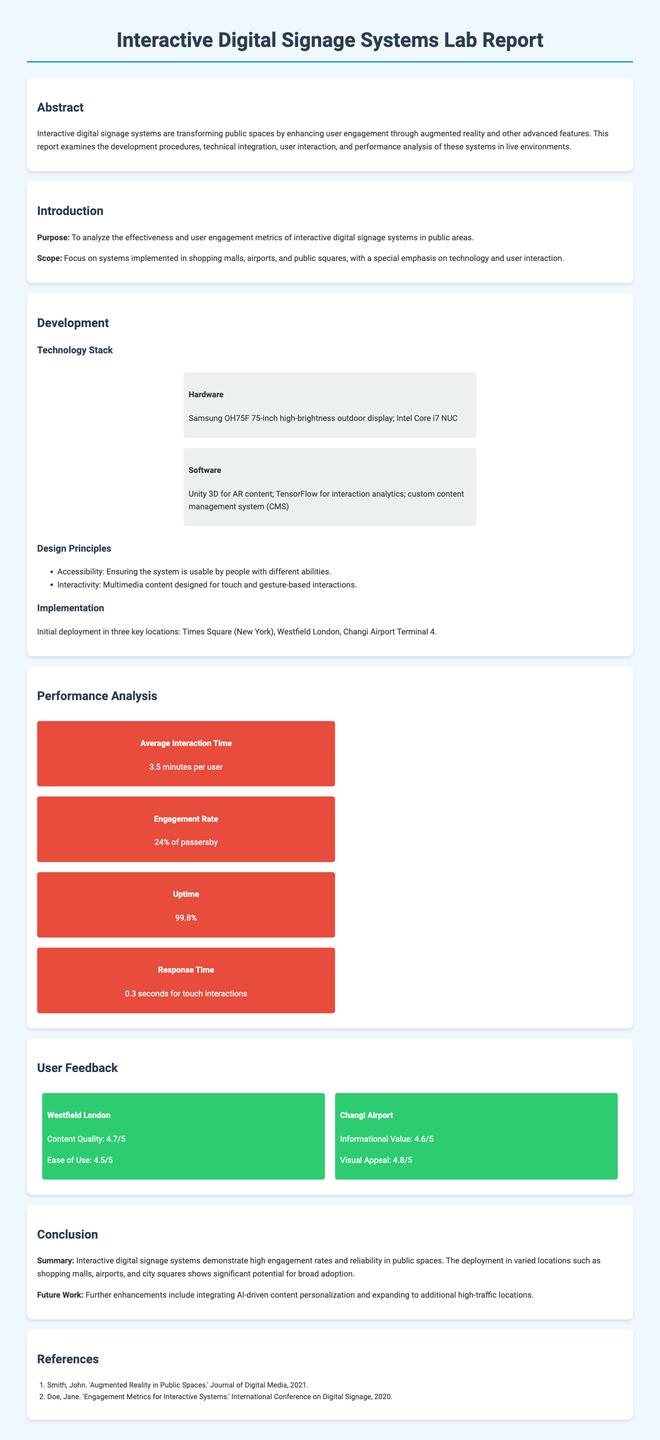What is the average interaction time? The average interaction time is specifically mentioned in the performance analysis section.
Answer: 3.5 minutes per user What is the engagement rate of the interactive digital signage systems? The engagement rate is detailed in the performance analysis section.
Answer: 24% of passersby Which airport is mentioned in the implementation section? The implementation section lists the locations where the systems were deployed, including one airport.
Answer: Changi Airport Terminal 4 What software is used for AR content? The development section specifies the software involved in creating the AR experience.
Answer: Unity 3D What was the uptime reported for the systems? The performance analysis section reports this as a key metric.
Answer: 99.8% What was the content quality rating at Westfield London? User feedback provides specific ratings for different locations.
Answer: 4.7/5 What future work is suggested in the conclusion? The conclusion mentions specific enhancements planned for future development.
Answer: AI-driven content personalization What technology is used for interaction analytics? The development section indicates the software employed for this purpose.
Answer: TensorFlow What is the purpose of the report? The introduction section clearly states the primary objective of the research.
Answer: To analyze the effectiveness and user engagement metrics 